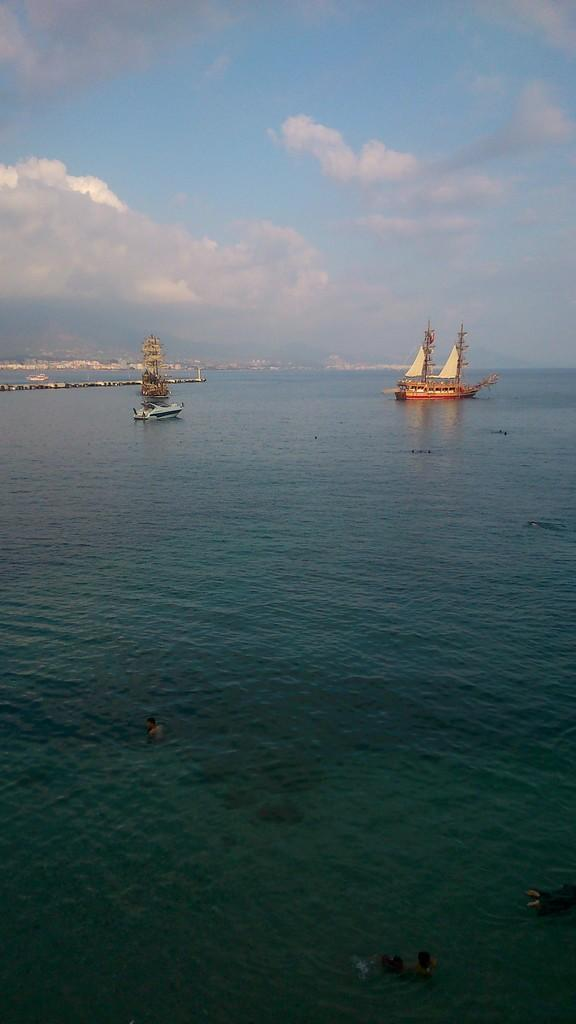What is in the foreground of the image? There is a water surface in the foreground of the image. What can be seen on the water surface? Ships are visible in the image. What is visible in the background of the image? There appear to be buildings and the sky in the background of the image. Is there a payment due for the birthday celebration in the image? There is no mention of a birthday celebration or payment in the image. Is it raining in the image? The provided facts do not mention any weather conditions, so we cannot determine if it is raining in the image. 